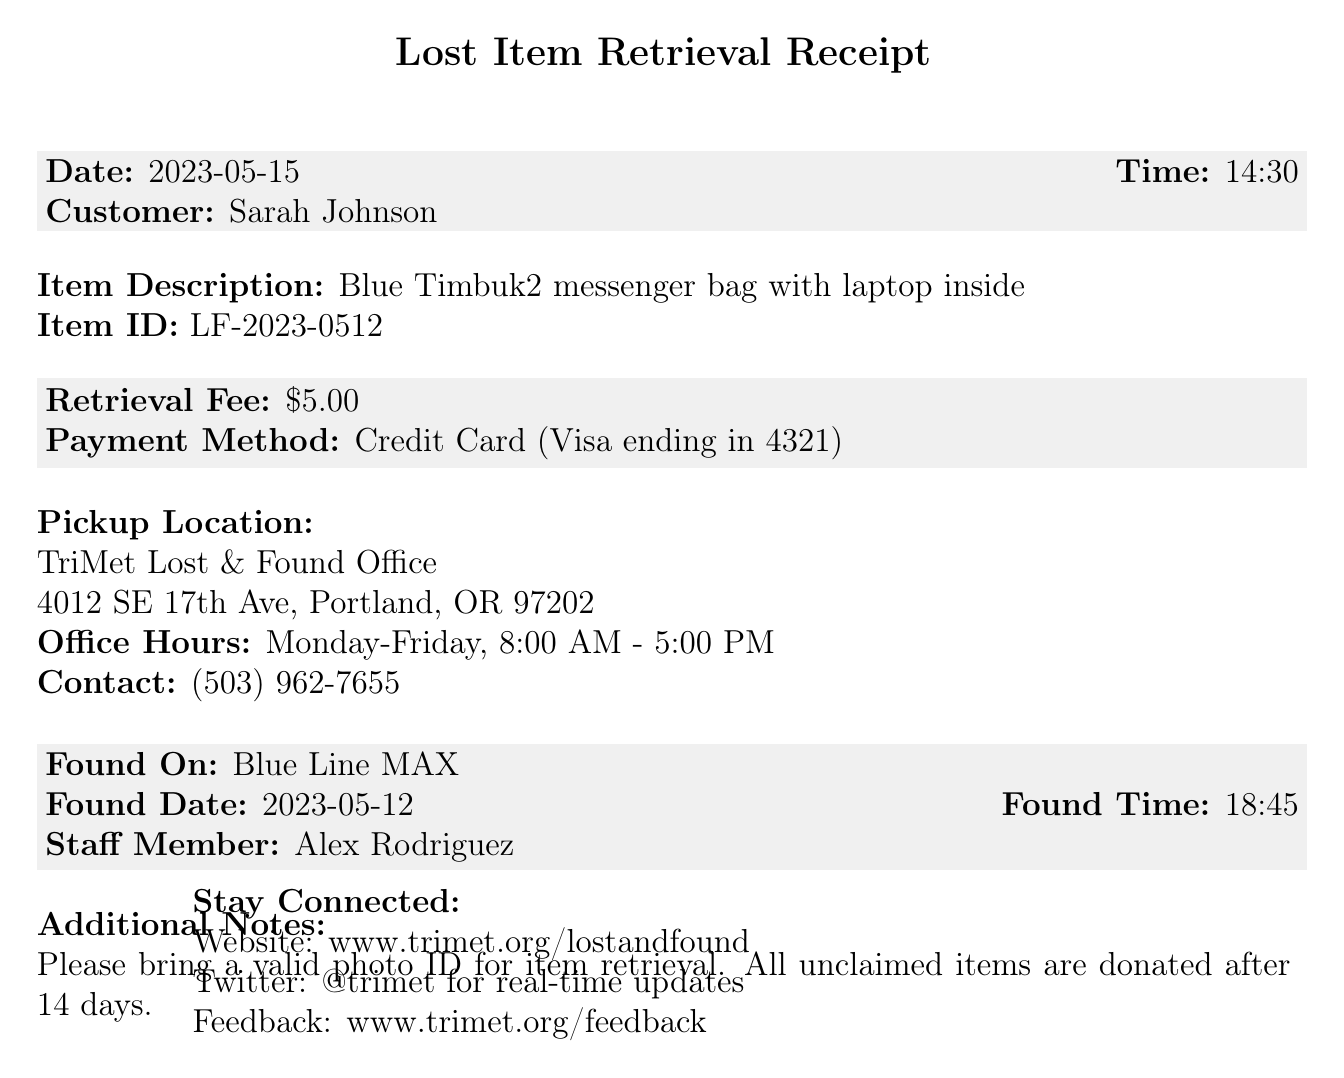What is the receipt number? The receipt number is a unique identifier for this retrieval receipt, which is LF23-7851.
Answer: LF23-7851 What is the item description? The item description provides details about the lost item, which in this case is a blue Timbuk2 messenger bag with a laptop inside.
Answer: Blue Timbuk2 messenger bag with laptop inside What is the retrieval fee? The retrieval fee is the amount charged for retrieving the lost item, noted as $5.00.
Answer: $5.00 When was the item found? The found date indicates when the item was discovered, which is specified as 2023-05-12.
Answer: 2023-05-12 What is the pickup location? The pickup location specifies where the item can be collected, which is the TriMet Lost & Found Office at 4012 SE 17th Ave, Portland, OR 97202.
Answer: TriMet Lost & Found Office, 4012 SE 17th Ave, Portland, OR 97202 Why is a photo ID required for item retrieval? A photo ID is required as a security measure to confirm the identity of the person retrieving the lost item.
Answer: Security measure How long are unclaimed items held before donation? The document notes a specific duration after which unclaimed items will be donated to ensure they are not held indefinitely.
Answer: 14 days What payment method was used? The document specifies the method of payment for the retrieval fee, which is Credit Card (Visa ending in 4321).
Answer: Credit Card (Visa ending in 4321) What are the office hours? The office hours indicate when the TriMet Lost & Found Office is open, which is Monday to Friday, between 8:00 AM and 5:00 PM.
Answer: Monday-Friday, 8:00 AM - 5:00 PM 